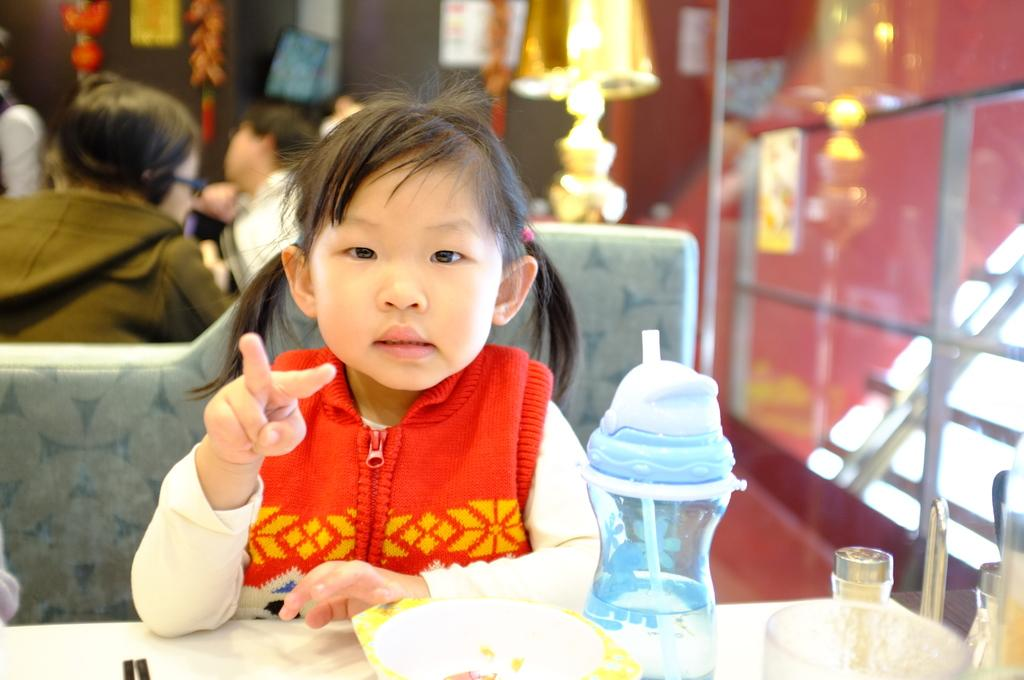What is the main subject of the image? There is a child in the image. What is the child doing in the image? The child is sitting on a chair. Where is the child positioned in relation to the table? The child is in front of a table. Can you describe the presence of other people in the image? There are other people behind the child. What type of disease is the child suffering from in the image? There is no indication of any disease in the image; it simply shows a child sitting on a chair in front of a table. Can you tell me how many cups are visible on the table in the image? There is no mention of cups in the image; it only shows a child sitting on a chair in front of a table with other people behind them. 